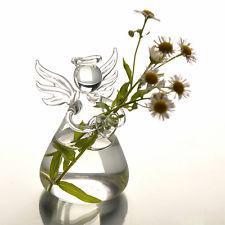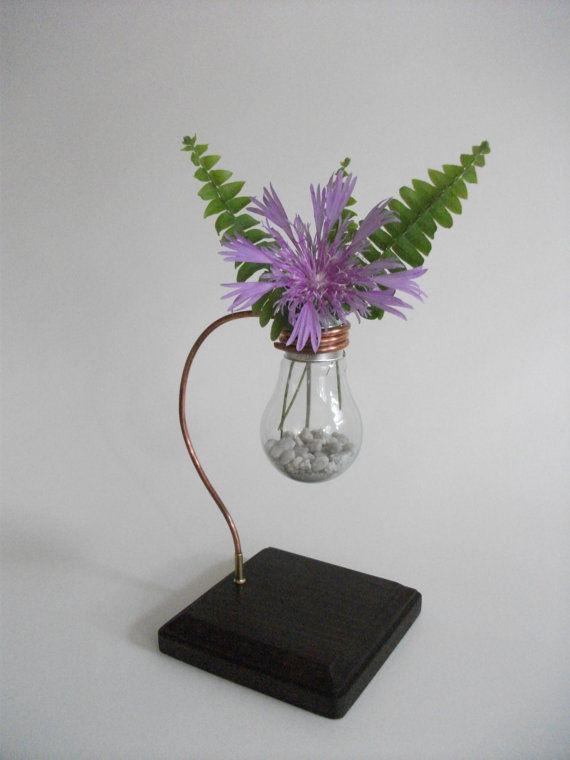The first image is the image on the left, the second image is the image on the right. For the images shown, is this caption "Two artichoke shaped vases contain plants." true? Answer yes or no. No. 